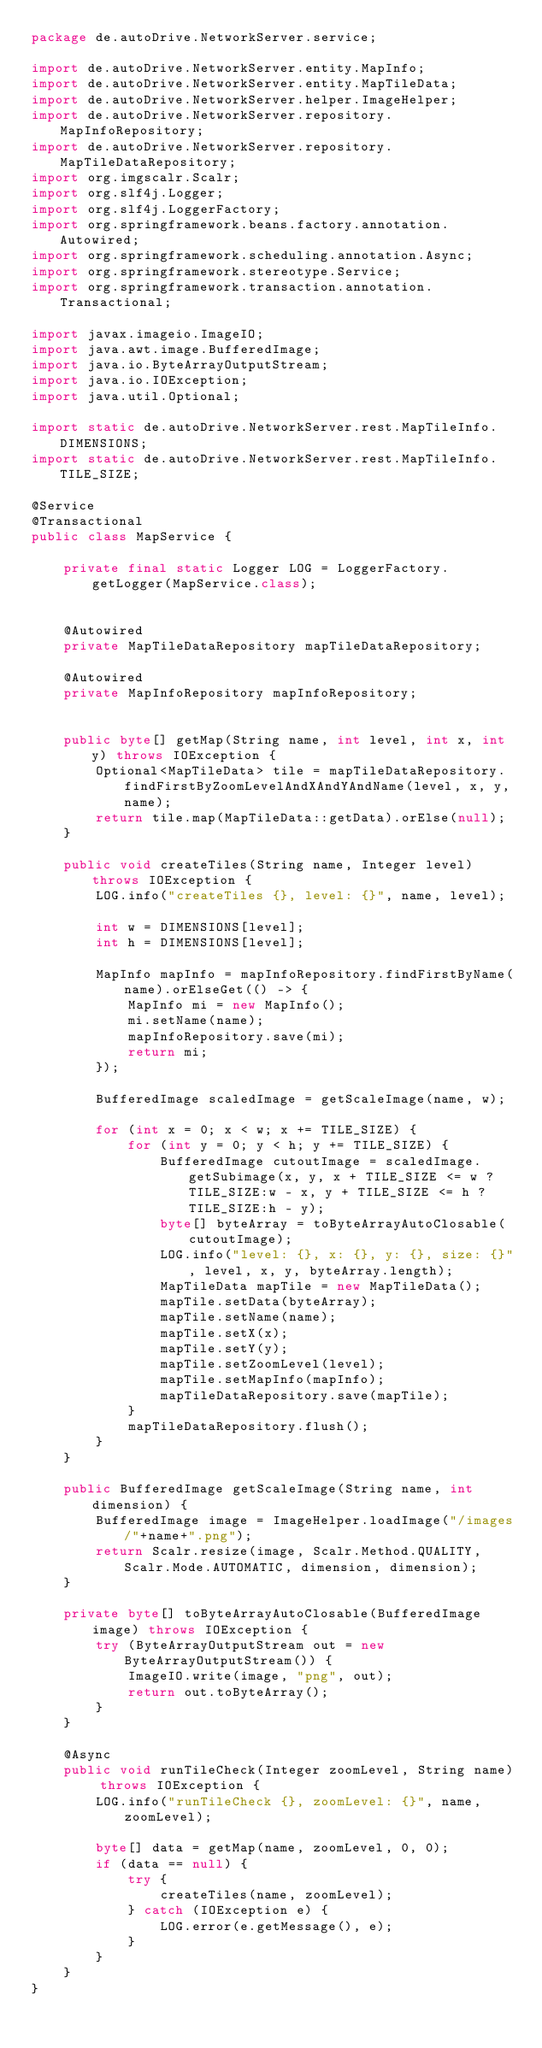<code> <loc_0><loc_0><loc_500><loc_500><_Java_>package de.autoDrive.NetworkServer.service;

import de.autoDrive.NetworkServer.entity.MapInfo;
import de.autoDrive.NetworkServer.entity.MapTileData;
import de.autoDrive.NetworkServer.helper.ImageHelper;
import de.autoDrive.NetworkServer.repository.MapInfoRepository;
import de.autoDrive.NetworkServer.repository.MapTileDataRepository;
import org.imgscalr.Scalr;
import org.slf4j.Logger;
import org.slf4j.LoggerFactory;
import org.springframework.beans.factory.annotation.Autowired;
import org.springframework.scheduling.annotation.Async;
import org.springframework.stereotype.Service;
import org.springframework.transaction.annotation.Transactional;

import javax.imageio.ImageIO;
import java.awt.image.BufferedImage;
import java.io.ByteArrayOutputStream;
import java.io.IOException;
import java.util.Optional;

import static de.autoDrive.NetworkServer.rest.MapTileInfo.DIMENSIONS;
import static de.autoDrive.NetworkServer.rest.MapTileInfo.TILE_SIZE;

@Service
@Transactional
public class MapService {

    private final static Logger LOG = LoggerFactory.getLogger(MapService.class);


    @Autowired
    private MapTileDataRepository mapTileDataRepository;

    @Autowired
    private MapInfoRepository mapInfoRepository;


    public byte[] getMap(String name, int level, int x, int y) throws IOException {
        Optional<MapTileData> tile = mapTileDataRepository.findFirstByZoomLevelAndXAndYAndName(level, x, y, name);
        return tile.map(MapTileData::getData).orElse(null);
    }

    public void createTiles(String name, Integer level) throws IOException {
        LOG.info("createTiles {}, level: {}", name, level);

        int w = DIMENSIONS[level];
        int h = DIMENSIONS[level];

        MapInfo mapInfo = mapInfoRepository.findFirstByName(name).orElseGet(() -> {
            MapInfo mi = new MapInfo();
            mi.setName(name);
            mapInfoRepository.save(mi);
            return mi;
        });

        BufferedImage scaledImage = getScaleImage(name, w);

        for (int x = 0; x < w; x += TILE_SIZE) {
            for (int y = 0; y < h; y += TILE_SIZE) {
                BufferedImage cutoutImage = scaledImage.getSubimage(x, y, x + TILE_SIZE <= w ? TILE_SIZE:w - x, y + TILE_SIZE <= h ? TILE_SIZE:h - y);
                byte[] byteArray = toByteArrayAutoClosable(cutoutImage);
                LOG.info("level: {}, x: {}, y: {}, size: {}", level, x, y, byteArray.length);
                MapTileData mapTile = new MapTileData();
                mapTile.setData(byteArray);
                mapTile.setName(name);
                mapTile.setX(x);
                mapTile.setY(y);
                mapTile.setZoomLevel(level);
                mapTile.setMapInfo(mapInfo);
                mapTileDataRepository.save(mapTile);
            }
            mapTileDataRepository.flush();
        }
    }

    public BufferedImage getScaleImage(String name, int dimension) {
        BufferedImage image = ImageHelper.loadImage("/images/"+name+".png");
        return Scalr.resize(image, Scalr.Method.QUALITY, Scalr.Mode.AUTOMATIC, dimension, dimension);
    }

    private byte[] toByteArrayAutoClosable(BufferedImage image) throws IOException {
        try (ByteArrayOutputStream out = new ByteArrayOutputStream()) {
            ImageIO.write(image, "png", out);
            return out.toByteArray();
        }
    }

    @Async
    public void runTileCheck(Integer zoomLevel, String name) throws IOException {
        LOG.info("runTileCheck {}, zoomLevel: {}", name, zoomLevel);

        byte[] data = getMap(name, zoomLevel, 0, 0);
        if (data == null) {
            try {
                createTiles(name, zoomLevel);
            } catch (IOException e) {
                LOG.error(e.getMessage(), e);
            }
        }
    }
}
</code> 